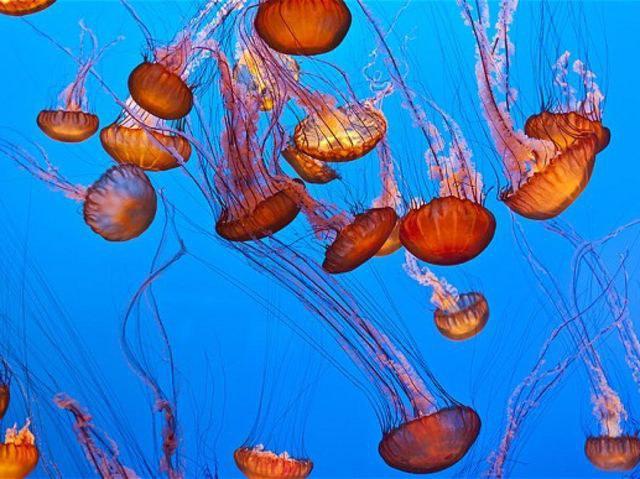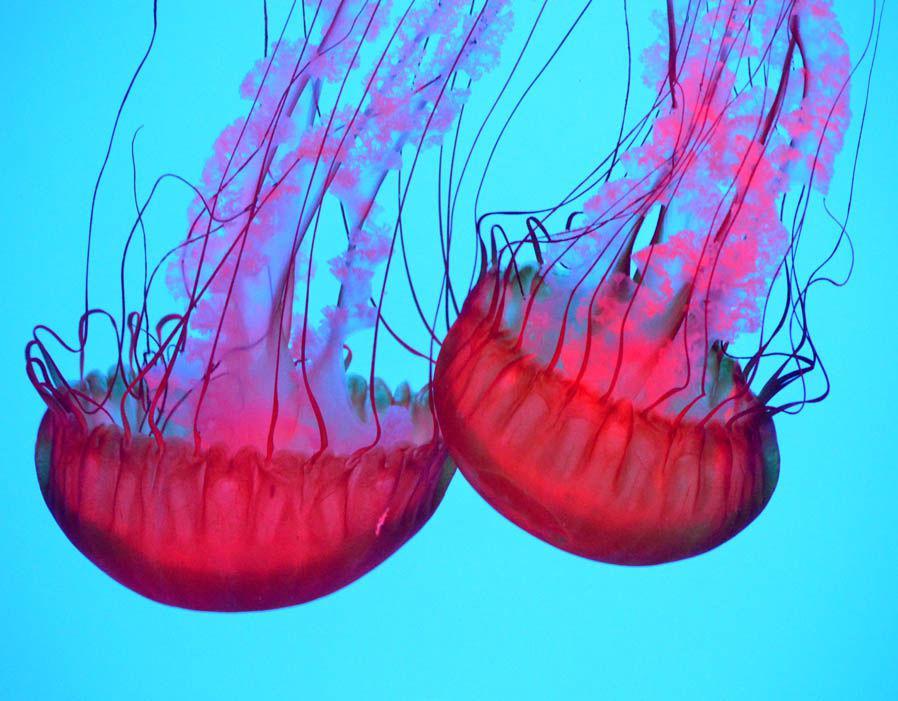The first image is the image on the left, the second image is the image on the right. Evaluate the accuracy of this statement regarding the images: "Each image includes at least six orange jellyfish with long tendrils.". Is it true? Answer yes or no. No. 